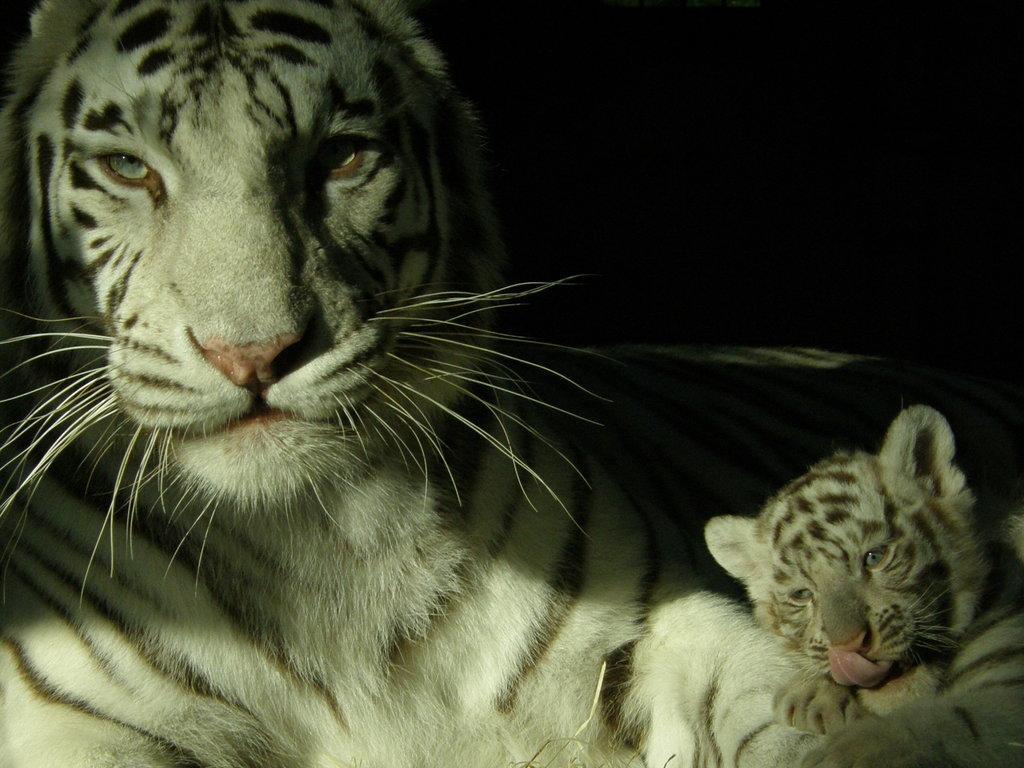Describe this image in one or two sentences. In this picture we can see two animals and in the background it is dark. 